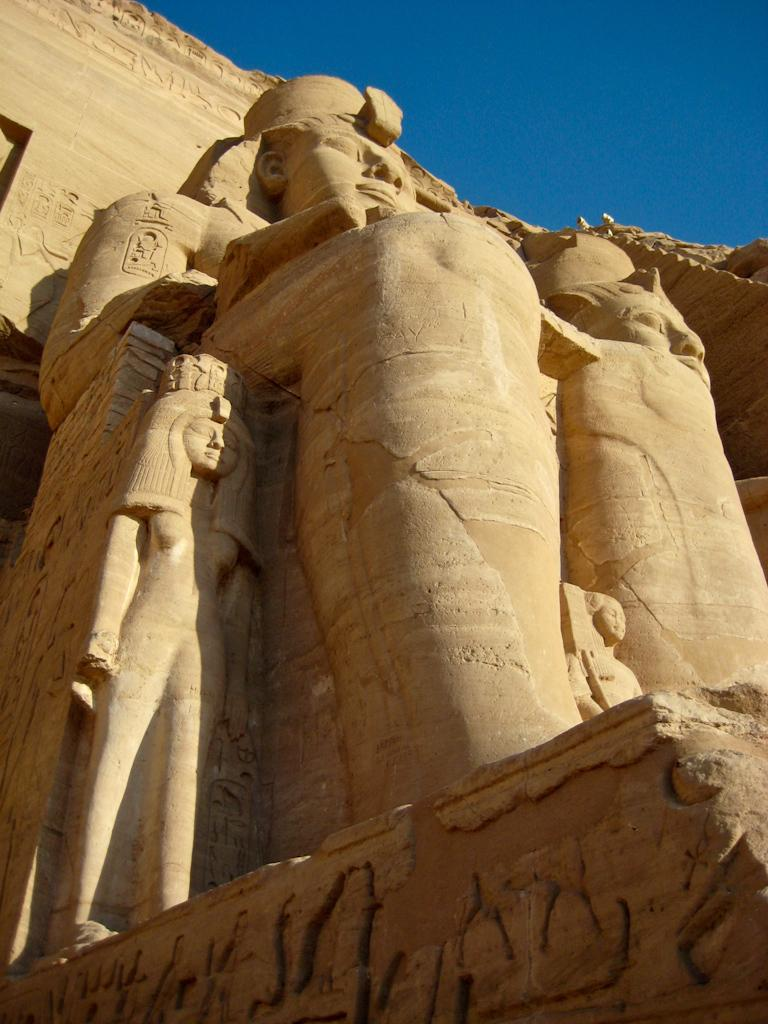What can be seen on the wall in the image? There are huge sculptures carved on the wall in the image. How is the lighting in the image? There is bright sunlight falling on the sculptures in the image. What type of celery can be seen growing near the sculptures in the image? There is no celery present in the image; it only features huge sculptures carved on the wall and bright sunlight. Can you tell me how many people are playing near the sculptures in the image? There is no indication of people playing or any other activity involving people in the image. 